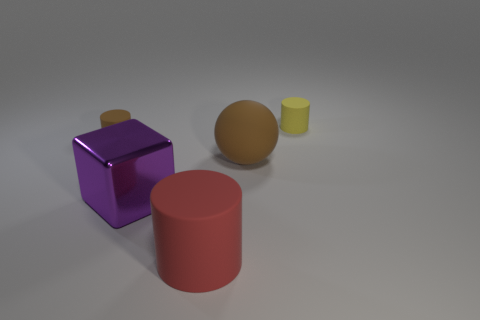Add 3 tiny brown rubber cylinders. How many objects exist? 8 Subtract all cubes. How many objects are left? 4 Add 5 red things. How many red things exist? 6 Subtract 0 red blocks. How many objects are left? 5 Subtract all yellow metal objects. Subtract all red cylinders. How many objects are left? 4 Add 3 purple cubes. How many purple cubes are left? 4 